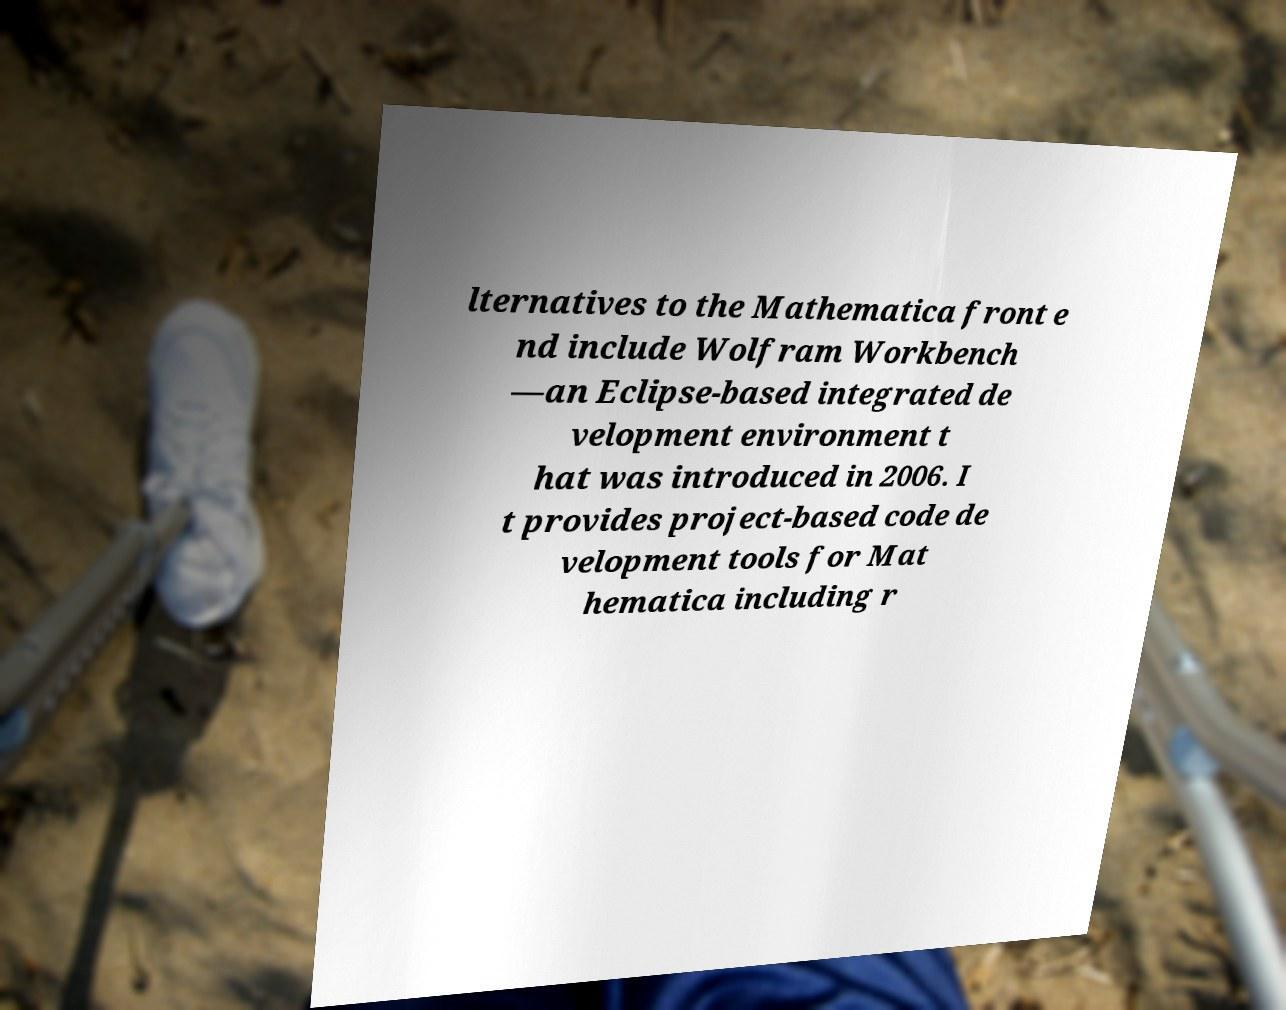Please identify and transcribe the text found in this image. lternatives to the Mathematica front e nd include Wolfram Workbench —an Eclipse-based integrated de velopment environment t hat was introduced in 2006. I t provides project-based code de velopment tools for Mat hematica including r 